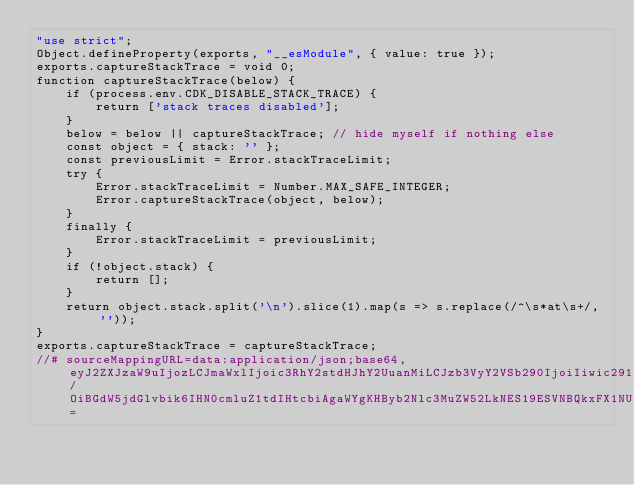Convert code to text. <code><loc_0><loc_0><loc_500><loc_500><_JavaScript_>"use strict";
Object.defineProperty(exports, "__esModule", { value: true });
exports.captureStackTrace = void 0;
function captureStackTrace(below) {
    if (process.env.CDK_DISABLE_STACK_TRACE) {
        return ['stack traces disabled'];
    }
    below = below || captureStackTrace; // hide myself if nothing else
    const object = { stack: '' };
    const previousLimit = Error.stackTraceLimit;
    try {
        Error.stackTraceLimit = Number.MAX_SAFE_INTEGER;
        Error.captureStackTrace(object, below);
    }
    finally {
        Error.stackTraceLimit = previousLimit;
    }
    if (!object.stack) {
        return [];
    }
    return object.stack.split('\n').slice(1).map(s => s.replace(/^\s*at\s+/, ''));
}
exports.captureStackTrace = captureStackTrace;
//# sourceMappingURL=data:application/json;base64,eyJ2ZXJzaW9uIjozLCJmaWxlIjoic3RhY2stdHJhY2UuanMiLCJzb3VyY2VSb290IjoiIiwic291cmNlcyI6WyJzdGFjay10cmFjZS50cyJdLCJuYW1lcyI6W10sIm1hcHBpbmdzIjoiOzs7QUFBQSxTQUFnQixpQkFBaUIsQ0FBQyxLQUFnQjtJQUNoRCxJQUFJLE9BQU8sQ0FBQyxHQUFHLENBQUMsdUJBQXVCLEVBQUU7UUFDdkMsT0FBTyxDQUFFLHVCQUF1QixDQUFFLENBQUM7S0FDcEM7SUFFRCxLQUFLLEdBQUcsS0FBSyxJQUFJLGlCQUFpQixDQUFDLENBQUMsOEJBQThCO0lBQ2xFLE1BQU0sTUFBTSxHQUFHLEVBQUUsS0FBSyxFQUFFLEVBQUUsRUFBRSxDQUFDO0lBQzdCLE1BQU0sYUFBYSxHQUFHLEtBQUssQ0FBQyxlQUFlLENBQUM7SUFDNUMsSUFBSTtRQUNGLEtBQUssQ0FBQyxlQUFlLEdBQUcsTUFBTSxDQUFDLGdCQUFnQixDQUFDO1FBQ2hELEtBQUssQ0FBQyxpQkFBaUIsQ0FBQyxNQUFNLEVBQUUsS0FBSyxDQUFDLENBQUM7S0FDeEM7WUFBUztRQUNSLEtBQUssQ0FBQyxlQUFlLEdBQUcsYUFBYSxDQUFDO0tBQ3ZDO0lBQ0QsSUFBSSxDQUFDLE1BQU0sQ0FBQyxLQUFLLEVBQUU7UUFDakIsT0FBTyxFQUFFLENBQUM7S0FDWDtJQUNELE9BQU8sTUFBTSxDQUFDLEtBQUssQ0FBQyxLQUFLLENBQUMsSUFBSSxDQUFDLENBQUMsS0FBSyxDQUFDLENBQUMsQ0FBQyxDQUFDLEdBQUcsQ0FBQyxDQUFDLENBQUMsRUFBRSxDQUFDLENBQUMsQ0FBQyxPQUFPLENBQUMsV0FBVyxFQUFFLEVBQUUsQ0FBQyxDQUFDLENBQUM7QUFDaEYsQ0FBQztBQWxCRCw4Q0FrQkMiLCJzb3VyY2VzQ29udGVudCI6WyJleHBvcnQgZnVuY3Rpb24gY2FwdHVyZVN0YWNrVHJhY2UoYmVsb3c/OiBGdW5jdGlvbik6IHN0cmluZ1tdIHtcbiAgaWYgKHByb2Nlc3MuZW52LkNES19ESVNBQkxFX1NUQUNLX1RSQUNFKSB7XG4gICAgcmV0dXJuIFsgJ3N0YWNrIHRyYWNlcyBkaXNhYmxlZCcgXTtcbiAgfVxuXG4gIGJlbG93ID0gYmVsb3cgfHwgY2FwdHVyZVN0YWNrVHJhY2U7IC8vIGhpZGUgbXlzZWxmIGlmIG5vdGhpbmcgZWxzZVxuICBjb25zdCBvYmplY3QgPSB7IHN0YWNrOiAnJyB9O1xuICBjb25zdCBwcmV2aW91c0xpbWl0ID0gRXJyb3Iuc3RhY2tUcmFjZUxpbWl0O1xuICB0cnkge1xuICAgIEVycm9yLnN0YWNrVHJhY2VMaW1pdCA9IE51bWJlci5NQVhfU0FGRV9JTlRFR0VSO1xuICAgIEVycm9yLmNhcHR1cmVTdGFja1RyYWNlKG9iamVjdCwgYmVsb3cpO1xuICB9IGZpbmFsbHkge1xuICAgIEVycm9yLnN0YWNrVHJhY2VMaW1pdCA9IHByZXZpb3VzTGltaXQ7XG4gIH1cbiAgaWYgKCFvYmplY3Quc3RhY2spIHtcbiAgICByZXR1cm4gW107XG4gIH1cbiAgcmV0dXJuIG9iamVjdC5zdGFjay5zcGxpdCgnXFxuJykuc2xpY2UoMSkubWFwKHMgPT4gcy5yZXBsYWNlKC9eXFxzKmF0XFxzKy8sICcnKSk7XG59XG4iXX0=</code> 